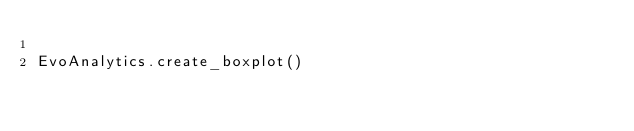Convert code to text. <code><loc_0><loc_0><loc_500><loc_500><_Python_>
EvoAnalytics.create_boxplot()
</code> 